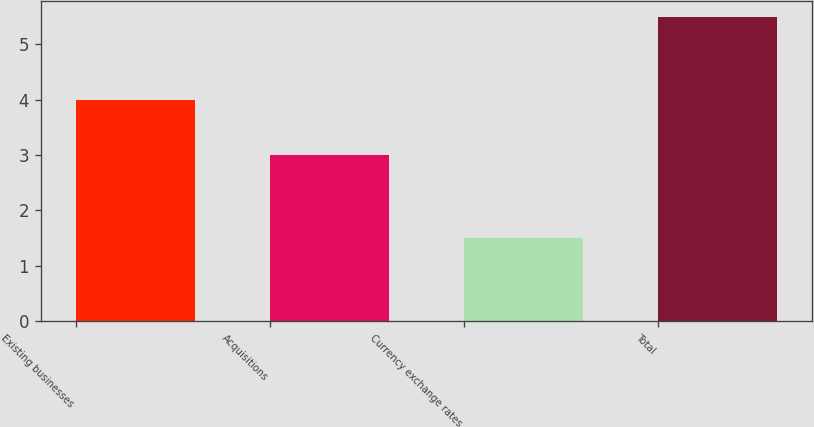<chart> <loc_0><loc_0><loc_500><loc_500><bar_chart><fcel>Existing businesses<fcel>Acquisitions<fcel>Currency exchange rates<fcel>Total<nl><fcel>4<fcel>3<fcel>1.5<fcel>5.5<nl></chart> 